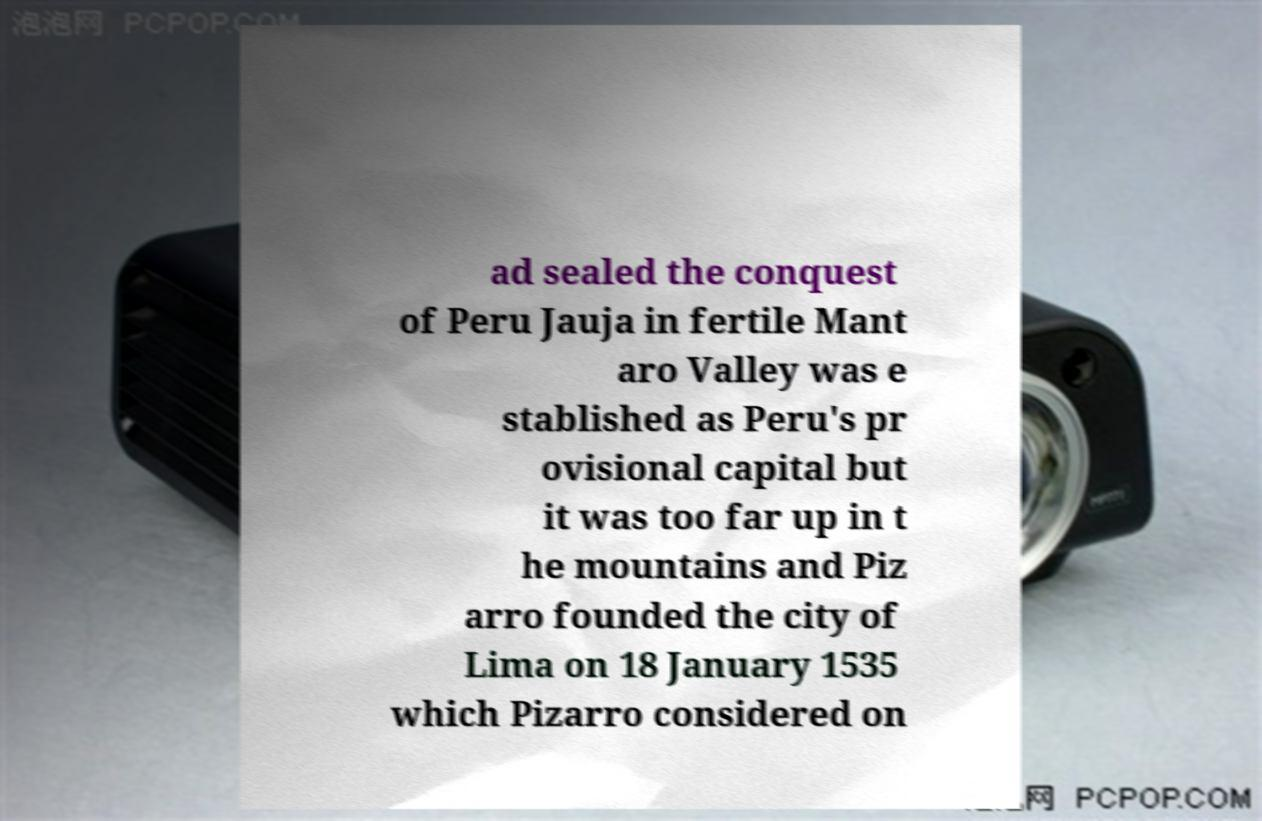Can you accurately transcribe the text from the provided image for me? ad sealed the conquest of Peru Jauja in fertile Mant aro Valley was e stablished as Peru's pr ovisional capital but it was too far up in t he mountains and Piz arro founded the city of Lima on 18 January 1535 which Pizarro considered on 